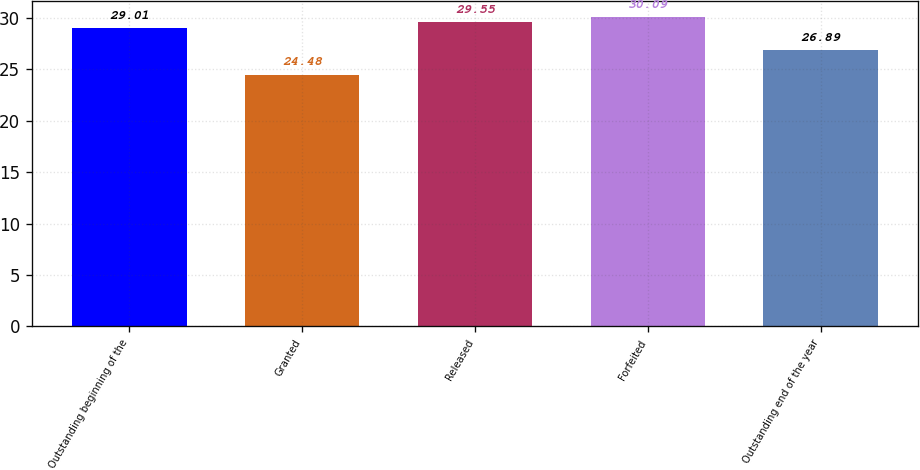Convert chart to OTSL. <chart><loc_0><loc_0><loc_500><loc_500><bar_chart><fcel>Outstanding beginning of the<fcel>Granted<fcel>Released<fcel>Forfeited<fcel>Outstanding end of the year<nl><fcel>29.01<fcel>24.48<fcel>29.55<fcel>30.09<fcel>26.89<nl></chart> 